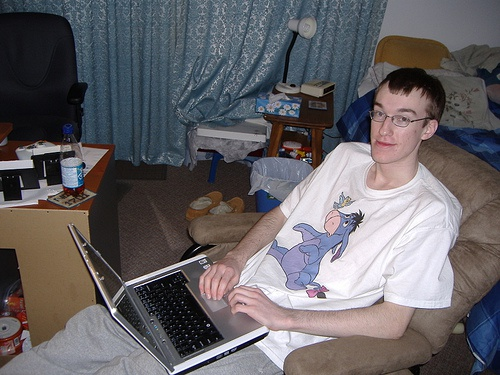Describe the objects in this image and their specific colors. I can see people in black, lavender, darkgray, and gray tones, chair in black and gray tones, laptop in black, gray, lavender, and darkgray tones, bed in black, gray, and maroon tones, and chair in black, darkblue, and maroon tones in this image. 